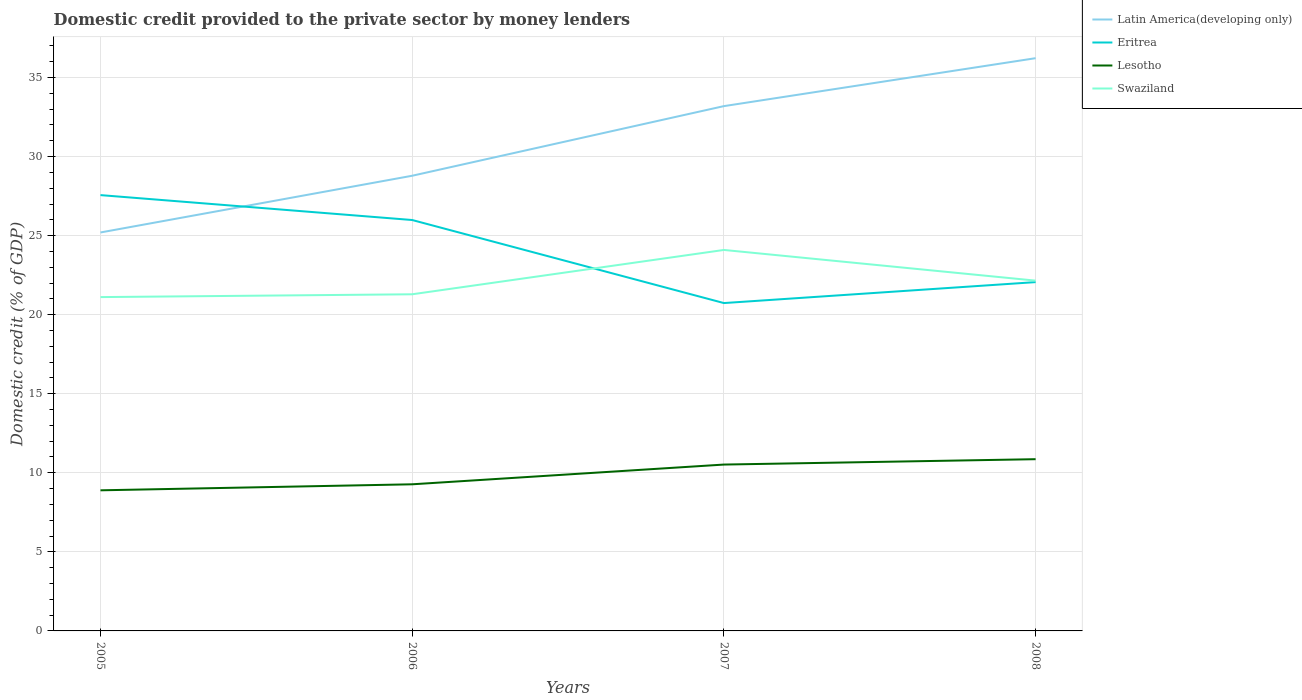How many different coloured lines are there?
Provide a short and direct response. 4. Across all years, what is the maximum domestic credit provided to the private sector by money lenders in Lesotho?
Make the answer very short. 8.89. What is the total domestic credit provided to the private sector by money lenders in Latin America(developing only) in the graph?
Your answer should be very brief. -7.44. What is the difference between the highest and the second highest domestic credit provided to the private sector by money lenders in Eritrea?
Make the answer very short. 6.83. Does the graph contain grids?
Offer a very short reply. Yes. Where does the legend appear in the graph?
Make the answer very short. Top right. How are the legend labels stacked?
Ensure brevity in your answer.  Vertical. What is the title of the graph?
Make the answer very short. Domestic credit provided to the private sector by money lenders. Does "Bahrain" appear as one of the legend labels in the graph?
Give a very brief answer. No. What is the label or title of the X-axis?
Ensure brevity in your answer.  Years. What is the label or title of the Y-axis?
Provide a succinct answer. Domestic credit (% of GDP). What is the Domestic credit (% of GDP) in Latin America(developing only) in 2005?
Your response must be concise. 25.2. What is the Domestic credit (% of GDP) in Eritrea in 2005?
Your response must be concise. 27.56. What is the Domestic credit (% of GDP) in Lesotho in 2005?
Provide a succinct answer. 8.89. What is the Domestic credit (% of GDP) of Swaziland in 2005?
Your answer should be very brief. 21.11. What is the Domestic credit (% of GDP) of Latin America(developing only) in 2006?
Keep it short and to the point. 28.79. What is the Domestic credit (% of GDP) in Eritrea in 2006?
Offer a terse response. 25.99. What is the Domestic credit (% of GDP) in Lesotho in 2006?
Give a very brief answer. 9.27. What is the Domestic credit (% of GDP) of Swaziland in 2006?
Ensure brevity in your answer.  21.29. What is the Domestic credit (% of GDP) of Latin America(developing only) in 2007?
Ensure brevity in your answer.  33.19. What is the Domestic credit (% of GDP) in Eritrea in 2007?
Keep it short and to the point. 20.74. What is the Domestic credit (% of GDP) in Lesotho in 2007?
Your answer should be very brief. 10.52. What is the Domestic credit (% of GDP) in Swaziland in 2007?
Your answer should be compact. 24.09. What is the Domestic credit (% of GDP) of Latin America(developing only) in 2008?
Provide a succinct answer. 36.22. What is the Domestic credit (% of GDP) in Eritrea in 2008?
Offer a terse response. 22.06. What is the Domestic credit (% of GDP) in Lesotho in 2008?
Your answer should be compact. 10.86. What is the Domestic credit (% of GDP) in Swaziland in 2008?
Your answer should be very brief. 22.15. Across all years, what is the maximum Domestic credit (% of GDP) of Latin America(developing only)?
Keep it short and to the point. 36.22. Across all years, what is the maximum Domestic credit (% of GDP) of Eritrea?
Offer a terse response. 27.56. Across all years, what is the maximum Domestic credit (% of GDP) in Lesotho?
Offer a terse response. 10.86. Across all years, what is the maximum Domestic credit (% of GDP) of Swaziland?
Offer a terse response. 24.09. Across all years, what is the minimum Domestic credit (% of GDP) in Latin America(developing only)?
Make the answer very short. 25.2. Across all years, what is the minimum Domestic credit (% of GDP) in Eritrea?
Ensure brevity in your answer.  20.74. Across all years, what is the minimum Domestic credit (% of GDP) in Lesotho?
Your answer should be compact. 8.89. Across all years, what is the minimum Domestic credit (% of GDP) in Swaziland?
Your answer should be compact. 21.11. What is the total Domestic credit (% of GDP) in Latin America(developing only) in the graph?
Offer a very short reply. 123.4. What is the total Domestic credit (% of GDP) of Eritrea in the graph?
Give a very brief answer. 96.35. What is the total Domestic credit (% of GDP) of Lesotho in the graph?
Your answer should be very brief. 39.55. What is the total Domestic credit (% of GDP) of Swaziland in the graph?
Ensure brevity in your answer.  88.65. What is the difference between the Domestic credit (% of GDP) of Latin America(developing only) in 2005 and that in 2006?
Offer a terse response. -3.59. What is the difference between the Domestic credit (% of GDP) of Eritrea in 2005 and that in 2006?
Ensure brevity in your answer.  1.57. What is the difference between the Domestic credit (% of GDP) of Lesotho in 2005 and that in 2006?
Keep it short and to the point. -0.38. What is the difference between the Domestic credit (% of GDP) of Swaziland in 2005 and that in 2006?
Keep it short and to the point. -0.18. What is the difference between the Domestic credit (% of GDP) in Latin America(developing only) in 2005 and that in 2007?
Keep it short and to the point. -7.99. What is the difference between the Domestic credit (% of GDP) of Eritrea in 2005 and that in 2007?
Give a very brief answer. 6.83. What is the difference between the Domestic credit (% of GDP) in Lesotho in 2005 and that in 2007?
Ensure brevity in your answer.  -1.63. What is the difference between the Domestic credit (% of GDP) in Swaziland in 2005 and that in 2007?
Your response must be concise. -2.98. What is the difference between the Domestic credit (% of GDP) in Latin America(developing only) in 2005 and that in 2008?
Your response must be concise. -11.02. What is the difference between the Domestic credit (% of GDP) of Eritrea in 2005 and that in 2008?
Your response must be concise. 5.5. What is the difference between the Domestic credit (% of GDP) of Lesotho in 2005 and that in 2008?
Ensure brevity in your answer.  -1.97. What is the difference between the Domestic credit (% of GDP) of Swaziland in 2005 and that in 2008?
Provide a succinct answer. -1.04. What is the difference between the Domestic credit (% of GDP) in Latin America(developing only) in 2006 and that in 2007?
Give a very brief answer. -4.4. What is the difference between the Domestic credit (% of GDP) of Eritrea in 2006 and that in 2007?
Your answer should be compact. 5.25. What is the difference between the Domestic credit (% of GDP) in Lesotho in 2006 and that in 2007?
Provide a succinct answer. -1.25. What is the difference between the Domestic credit (% of GDP) of Swaziland in 2006 and that in 2007?
Offer a terse response. -2.8. What is the difference between the Domestic credit (% of GDP) in Latin America(developing only) in 2006 and that in 2008?
Keep it short and to the point. -7.44. What is the difference between the Domestic credit (% of GDP) in Eritrea in 2006 and that in 2008?
Your answer should be compact. 3.93. What is the difference between the Domestic credit (% of GDP) of Lesotho in 2006 and that in 2008?
Make the answer very short. -1.59. What is the difference between the Domestic credit (% of GDP) of Swaziland in 2006 and that in 2008?
Offer a very short reply. -0.86. What is the difference between the Domestic credit (% of GDP) in Latin America(developing only) in 2007 and that in 2008?
Ensure brevity in your answer.  -3.03. What is the difference between the Domestic credit (% of GDP) in Eritrea in 2007 and that in 2008?
Offer a terse response. -1.33. What is the difference between the Domestic credit (% of GDP) of Lesotho in 2007 and that in 2008?
Offer a terse response. -0.34. What is the difference between the Domestic credit (% of GDP) in Swaziland in 2007 and that in 2008?
Keep it short and to the point. 1.94. What is the difference between the Domestic credit (% of GDP) in Latin America(developing only) in 2005 and the Domestic credit (% of GDP) in Eritrea in 2006?
Offer a terse response. -0.79. What is the difference between the Domestic credit (% of GDP) of Latin America(developing only) in 2005 and the Domestic credit (% of GDP) of Lesotho in 2006?
Make the answer very short. 15.93. What is the difference between the Domestic credit (% of GDP) in Latin America(developing only) in 2005 and the Domestic credit (% of GDP) in Swaziland in 2006?
Offer a terse response. 3.91. What is the difference between the Domestic credit (% of GDP) in Eritrea in 2005 and the Domestic credit (% of GDP) in Lesotho in 2006?
Ensure brevity in your answer.  18.29. What is the difference between the Domestic credit (% of GDP) of Eritrea in 2005 and the Domestic credit (% of GDP) of Swaziland in 2006?
Make the answer very short. 6.27. What is the difference between the Domestic credit (% of GDP) of Lesotho in 2005 and the Domestic credit (% of GDP) of Swaziland in 2006?
Provide a succinct answer. -12.4. What is the difference between the Domestic credit (% of GDP) of Latin America(developing only) in 2005 and the Domestic credit (% of GDP) of Eritrea in 2007?
Offer a terse response. 4.46. What is the difference between the Domestic credit (% of GDP) of Latin America(developing only) in 2005 and the Domestic credit (% of GDP) of Lesotho in 2007?
Make the answer very short. 14.68. What is the difference between the Domestic credit (% of GDP) in Latin America(developing only) in 2005 and the Domestic credit (% of GDP) in Swaziland in 2007?
Ensure brevity in your answer.  1.11. What is the difference between the Domestic credit (% of GDP) in Eritrea in 2005 and the Domestic credit (% of GDP) in Lesotho in 2007?
Provide a succinct answer. 17.04. What is the difference between the Domestic credit (% of GDP) in Eritrea in 2005 and the Domestic credit (% of GDP) in Swaziland in 2007?
Offer a terse response. 3.47. What is the difference between the Domestic credit (% of GDP) in Lesotho in 2005 and the Domestic credit (% of GDP) in Swaziland in 2007?
Give a very brief answer. -15.2. What is the difference between the Domestic credit (% of GDP) of Latin America(developing only) in 2005 and the Domestic credit (% of GDP) of Eritrea in 2008?
Keep it short and to the point. 3.14. What is the difference between the Domestic credit (% of GDP) in Latin America(developing only) in 2005 and the Domestic credit (% of GDP) in Lesotho in 2008?
Keep it short and to the point. 14.34. What is the difference between the Domestic credit (% of GDP) of Latin America(developing only) in 2005 and the Domestic credit (% of GDP) of Swaziland in 2008?
Keep it short and to the point. 3.05. What is the difference between the Domestic credit (% of GDP) of Eritrea in 2005 and the Domestic credit (% of GDP) of Lesotho in 2008?
Provide a short and direct response. 16.7. What is the difference between the Domestic credit (% of GDP) of Eritrea in 2005 and the Domestic credit (% of GDP) of Swaziland in 2008?
Keep it short and to the point. 5.41. What is the difference between the Domestic credit (% of GDP) of Lesotho in 2005 and the Domestic credit (% of GDP) of Swaziland in 2008?
Ensure brevity in your answer.  -13.26. What is the difference between the Domestic credit (% of GDP) of Latin America(developing only) in 2006 and the Domestic credit (% of GDP) of Eritrea in 2007?
Your answer should be very brief. 8.05. What is the difference between the Domestic credit (% of GDP) in Latin America(developing only) in 2006 and the Domestic credit (% of GDP) in Lesotho in 2007?
Provide a succinct answer. 18.27. What is the difference between the Domestic credit (% of GDP) in Latin America(developing only) in 2006 and the Domestic credit (% of GDP) in Swaziland in 2007?
Your response must be concise. 4.69. What is the difference between the Domestic credit (% of GDP) of Eritrea in 2006 and the Domestic credit (% of GDP) of Lesotho in 2007?
Your answer should be very brief. 15.47. What is the difference between the Domestic credit (% of GDP) of Eritrea in 2006 and the Domestic credit (% of GDP) of Swaziland in 2007?
Offer a very short reply. 1.89. What is the difference between the Domestic credit (% of GDP) in Lesotho in 2006 and the Domestic credit (% of GDP) in Swaziland in 2007?
Your answer should be compact. -14.82. What is the difference between the Domestic credit (% of GDP) of Latin America(developing only) in 2006 and the Domestic credit (% of GDP) of Eritrea in 2008?
Give a very brief answer. 6.73. What is the difference between the Domestic credit (% of GDP) of Latin America(developing only) in 2006 and the Domestic credit (% of GDP) of Lesotho in 2008?
Make the answer very short. 17.93. What is the difference between the Domestic credit (% of GDP) of Latin America(developing only) in 2006 and the Domestic credit (% of GDP) of Swaziland in 2008?
Your answer should be very brief. 6.63. What is the difference between the Domestic credit (% of GDP) of Eritrea in 2006 and the Domestic credit (% of GDP) of Lesotho in 2008?
Provide a succinct answer. 15.13. What is the difference between the Domestic credit (% of GDP) of Eritrea in 2006 and the Domestic credit (% of GDP) of Swaziland in 2008?
Give a very brief answer. 3.83. What is the difference between the Domestic credit (% of GDP) of Lesotho in 2006 and the Domestic credit (% of GDP) of Swaziland in 2008?
Offer a terse response. -12.88. What is the difference between the Domestic credit (% of GDP) of Latin America(developing only) in 2007 and the Domestic credit (% of GDP) of Eritrea in 2008?
Provide a succinct answer. 11.13. What is the difference between the Domestic credit (% of GDP) of Latin America(developing only) in 2007 and the Domestic credit (% of GDP) of Lesotho in 2008?
Make the answer very short. 22.33. What is the difference between the Domestic credit (% of GDP) in Latin America(developing only) in 2007 and the Domestic credit (% of GDP) in Swaziland in 2008?
Provide a short and direct response. 11.04. What is the difference between the Domestic credit (% of GDP) in Eritrea in 2007 and the Domestic credit (% of GDP) in Lesotho in 2008?
Give a very brief answer. 9.87. What is the difference between the Domestic credit (% of GDP) of Eritrea in 2007 and the Domestic credit (% of GDP) of Swaziland in 2008?
Give a very brief answer. -1.42. What is the difference between the Domestic credit (% of GDP) in Lesotho in 2007 and the Domestic credit (% of GDP) in Swaziland in 2008?
Ensure brevity in your answer.  -11.63. What is the average Domestic credit (% of GDP) of Latin America(developing only) per year?
Ensure brevity in your answer.  30.85. What is the average Domestic credit (% of GDP) of Eritrea per year?
Offer a terse response. 24.09. What is the average Domestic credit (% of GDP) in Lesotho per year?
Make the answer very short. 9.89. What is the average Domestic credit (% of GDP) in Swaziland per year?
Keep it short and to the point. 22.16. In the year 2005, what is the difference between the Domestic credit (% of GDP) in Latin America(developing only) and Domestic credit (% of GDP) in Eritrea?
Your answer should be very brief. -2.36. In the year 2005, what is the difference between the Domestic credit (% of GDP) of Latin America(developing only) and Domestic credit (% of GDP) of Lesotho?
Offer a terse response. 16.31. In the year 2005, what is the difference between the Domestic credit (% of GDP) of Latin America(developing only) and Domestic credit (% of GDP) of Swaziland?
Make the answer very short. 4.09. In the year 2005, what is the difference between the Domestic credit (% of GDP) of Eritrea and Domestic credit (% of GDP) of Lesotho?
Give a very brief answer. 18.67. In the year 2005, what is the difference between the Domestic credit (% of GDP) in Eritrea and Domestic credit (% of GDP) in Swaziland?
Provide a succinct answer. 6.45. In the year 2005, what is the difference between the Domestic credit (% of GDP) of Lesotho and Domestic credit (% of GDP) of Swaziland?
Make the answer very short. -12.22. In the year 2006, what is the difference between the Domestic credit (% of GDP) of Latin America(developing only) and Domestic credit (% of GDP) of Eritrea?
Your answer should be very brief. 2.8. In the year 2006, what is the difference between the Domestic credit (% of GDP) in Latin America(developing only) and Domestic credit (% of GDP) in Lesotho?
Make the answer very short. 19.51. In the year 2006, what is the difference between the Domestic credit (% of GDP) in Latin America(developing only) and Domestic credit (% of GDP) in Swaziland?
Provide a short and direct response. 7.5. In the year 2006, what is the difference between the Domestic credit (% of GDP) of Eritrea and Domestic credit (% of GDP) of Lesotho?
Give a very brief answer. 16.71. In the year 2006, what is the difference between the Domestic credit (% of GDP) in Eritrea and Domestic credit (% of GDP) in Swaziland?
Offer a very short reply. 4.7. In the year 2006, what is the difference between the Domestic credit (% of GDP) of Lesotho and Domestic credit (% of GDP) of Swaziland?
Your answer should be compact. -12.02. In the year 2007, what is the difference between the Domestic credit (% of GDP) of Latin America(developing only) and Domestic credit (% of GDP) of Eritrea?
Your answer should be compact. 12.46. In the year 2007, what is the difference between the Domestic credit (% of GDP) of Latin America(developing only) and Domestic credit (% of GDP) of Lesotho?
Offer a very short reply. 22.67. In the year 2007, what is the difference between the Domestic credit (% of GDP) of Latin America(developing only) and Domestic credit (% of GDP) of Swaziland?
Keep it short and to the point. 9.1. In the year 2007, what is the difference between the Domestic credit (% of GDP) in Eritrea and Domestic credit (% of GDP) in Lesotho?
Ensure brevity in your answer.  10.21. In the year 2007, what is the difference between the Domestic credit (% of GDP) in Eritrea and Domestic credit (% of GDP) in Swaziland?
Offer a terse response. -3.36. In the year 2007, what is the difference between the Domestic credit (% of GDP) of Lesotho and Domestic credit (% of GDP) of Swaziland?
Provide a short and direct response. -13.57. In the year 2008, what is the difference between the Domestic credit (% of GDP) of Latin America(developing only) and Domestic credit (% of GDP) of Eritrea?
Your answer should be compact. 14.16. In the year 2008, what is the difference between the Domestic credit (% of GDP) in Latin America(developing only) and Domestic credit (% of GDP) in Lesotho?
Keep it short and to the point. 25.36. In the year 2008, what is the difference between the Domestic credit (% of GDP) in Latin America(developing only) and Domestic credit (% of GDP) in Swaziland?
Make the answer very short. 14.07. In the year 2008, what is the difference between the Domestic credit (% of GDP) in Eritrea and Domestic credit (% of GDP) in Lesotho?
Offer a very short reply. 11.2. In the year 2008, what is the difference between the Domestic credit (% of GDP) in Eritrea and Domestic credit (% of GDP) in Swaziland?
Ensure brevity in your answer.  -0.09. In the year 2008, what is the difference between the Domestic credit (% of GDP) of Lesotho and Domestic credit (% of GDP) of Swaziland?
Make the answer very short. -11.29. What is the ratio of the Domestic credit (% of GDP) of Latin America(developing only) in 2005 to that in 2006?
Give a very brief answer. 0.88. What is the ratio of the Domestic credit (% of GDP) in Eritrea in 2005 to that in 2006?
Make the answer very short. 1.06. What is the ratio of the Domestic credit (% of GDP) of Swaziland in 2005 to that in 2006?
Make the answer very short. 0.99. What is the ratio of the Domestic credit (% of GDP) in Latin America(developing only) in 2005 to that in 2007?
Your answer should be very brief. 0.76. What is the ratio of the Domestic credit (% of GDP) in Eritrea in 2005 to that in 2007?
Offer a very short reply. 1.33. What is the ratio of the Domestic credit (% of GDP) of Lesotho in 2005 to that in 2007?
Give a very brief answer. 0.85. What is the ratio of the Domestic credit (% of GDP) in Swaziland in 2005 to that in 2007?
Offer a very short reply. 0.88. What is the ratio of the Domestic credit (% of GDP) in Latin America(developing only) in 2005 to that in 2008?
Give a very brief answer. 0.7. What is the ratio of the Domestic credit (% of GDP) of Eritrea in 2005 to that in 2008?
Your response must be concise. 1.25. What is the ratio of the Domestic credit (% of GDP) of Lesotho in 2005 to that in 2008?
Provide a succinct answer. 0.82. What is the ratio of the Domestic credit (% of GDP) of Swaziland in 2005 to that in 2008?
Provide a succinct answer. 0.95. What is the ratio of the Domestic credit (% of GDP) in Latin America(developing only) in 2006 to that in 2007?
Ensure brevity in your answer.  0.87. What is the ratio of the Domestic credit (% of GDP) in Eritrea in 2006 to that in 2007?
Keep it short and to the point. 1.25. What is the ratio of the Domestic credit (% of GDP) of Lesotho in 2006 to that in 2007?
Your answer should be compact. 0.88. What is the ratio of the Domestic credit (% of GDP) in Swaziland in 2006 to that in 2007?
Ensure brevity in your answer.  0.88. What is the ratio of the Domestic credit (% of GDP) of Latin America(developing only) in 2006 to that in 2008?
Your answer should be very brief. 0.79. What is the ratio of the Domestic credit (% of GDP) of Eritrea in 2006 to that in 2008?
Your response must be concise. 1.18. What is the ratio of the Domestic credit (% of GDP) in Lesotho in 2006 to that in 2008?
Provide a short and direct response. 0.85. What is the ratio of the Domestic credit (% of GDP) of Swaziland in 2006 to that in 2008?
Offer a very short reply. 0.96. What is the ratio of the Domestic credit (% of GDP) in Latin America(developing only) in 2007 to that in 2008?
Offer a very short reply. 0.92. What is the ratio of the Domestic credit (% of GDP) in Eritrea in 2007 to that in 2008?
Your answer should be very brief. 0.94. What is the ratio of the Domestic credit (% of GDP) of Lesotho in 2007 to that in 2008?
Your answer should be compact. 0.97. What is the ratio of the Domestic credit (% of GDP) of Swaziland in 2007 to that in 2008?
Keep it short and to the point. 1.09. What is the difference between the highest and the second highest Domestic credit (% of GDP) of Latin America(developing only)?
Your answer should be very brief. 3.03. What is the difference between the highest and the second highest Domestic credit (% of GDP) in Eritrea?
Your answer should be very brief. 1.57. What is the difference between the highest and the second highest Domestic credit (% of GDP) in Lesotho?
Your answer should be compact. 0.34. What is the difference between the highest and the second highest Domestic credit (% of GDP) of Swaziland?
Ensure brevity in your answer.  1.94. What is the difference between the highest and the lowest Domestic credit (% of GDP) of Latin America(developing only)?
Ensure brevity in your answer.  11.02. What is the difference between the highest and the lowest Domestic credit (% of GDP) in Eritrea?
Ensure brevity in your answer.  6.83. What is the difference between the highest and the lowest Domestic credit (% of GDP) in Lesotho?
Your answer should be very brief. 1.97. What is the difference between the highest and the lowest Domestic credit (% of GDP) in Swaziland?
Provide a succinct answer. 2.98. 